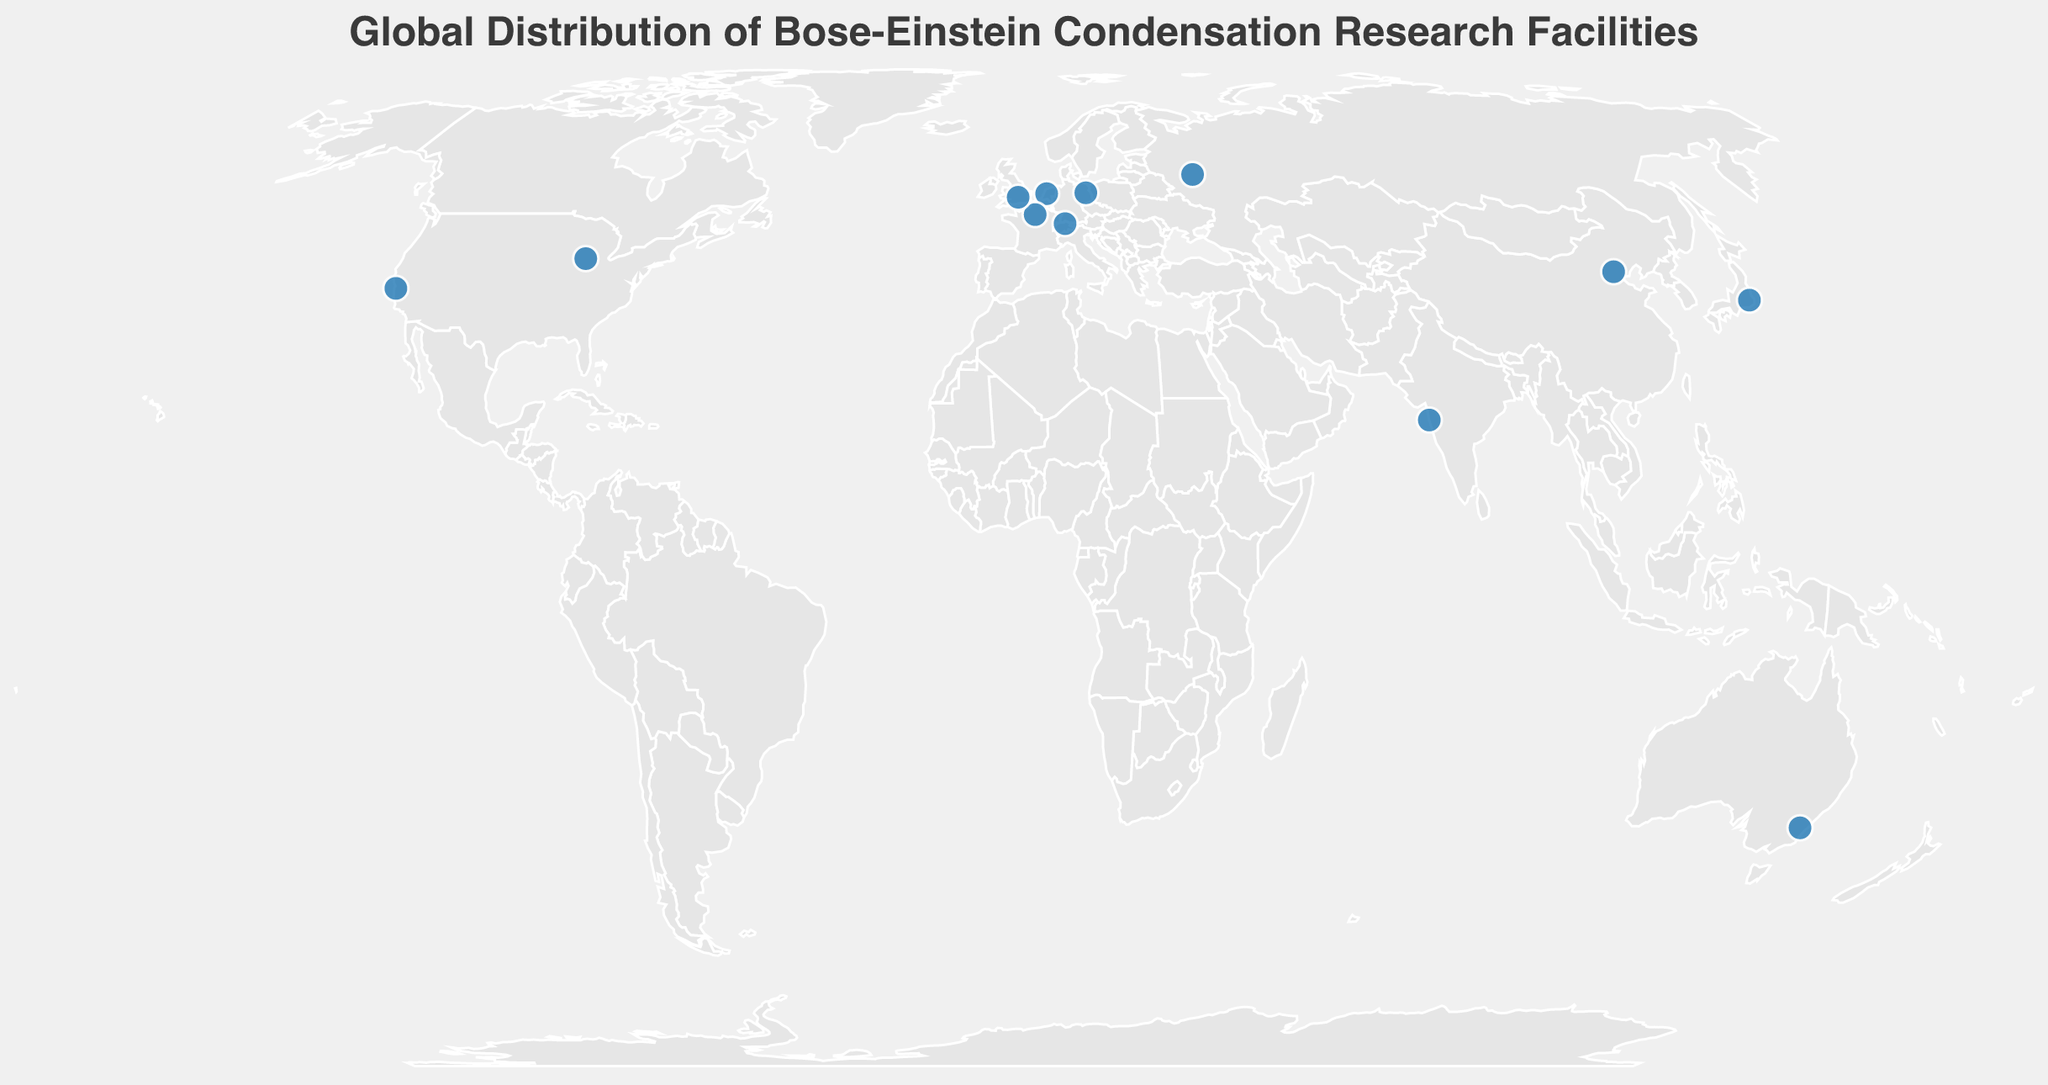What's the title of the figure? The title of the figure is displayed prominently at the top of the plot. It usually gives an overview of what the plot represents.
Answer: "Global Distribution of Bose-Einstein Condensation Research Facilities" How many research facilities are displayed in the figure? To answer this, count the number of data points (circular markers) on the geographic plot, representing research facilities. There are 12 circular markers on the plot.
Answer: 12 Which research facility focuses on "Quantum Gases in Optical Lattices"? Hovering over the data points to reveal the tooltips will show that the University of Amsterdam's focus area is "Quantum Gases in Optical Lattices".
Answer: University of Amsterdam Which country has the most research facilities conducting BEC experiments according to the plot? By analyzing the locations of the data points and their corresponding tooltips, it shows that the USA has two research facilities, which is the most among the listed countries.
Answer: USA What is the focus area of Tsinghua University in China? Hover over the marker located in China to reveal the tooltip. The tooltip indicates that Tsinghua University focuses on "BEC in Microgravity".
Answer: BEC in Microgravity What is the longitude and latitude of the facility focusing on "Topological Defects in BECs"? By examining the plot and hovering over relevant markers, you will find that the Russian Quantum Center focuses on "Topological Defects in BECs" and is located at Latitude 55.7558 and Longitude 37.6173.
Answer: Latitude 55.7558, Longitude 37.6173 Compare the focus areas of research facilities in the USA. What are the areas of focus? The USA has two facilities: Stanford University focuses on "Atom Interferometry with BECs", and the University of Chicago focuses on "Fermionic Superfluidity".
Answer: "Atom Interferometry with BECs", "Fermionic Superfluidity" How many research facilities focus on types of BECs involving superfluid states? From the tooltips, identify facilities with focus areas mentioning superfluid states: École Normale Supérieure (Superfluid Helium-4 BECs) and University of Chicago (Fermionic Superfluidity). There are 2 such facilities.
Answer: 2 Which facility is located furthest north geographically? By comparing the latitudes of all facilities, the one with the highest latitude is the furthest north. The Russian Quantum Center in Russia at Latitude 55.7558 is the furthest north.
Answer: Russian Quantum Center 